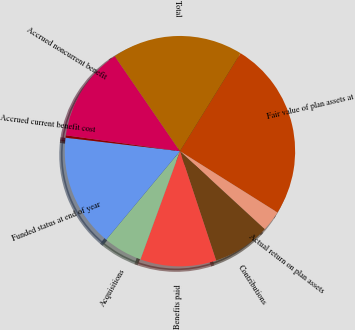Convert chart. <chart><loc_0><loc_0><loc_500><loc_500><pie_chart><fcel>Fair value of plan assets at<fcel>Actual return on plan assets<fcel>Contributions<fcel>Benefits paid<fcel>Acquisitions<fcel>Funded status at end of year<fcel>Accrued current benefit cost<fcel>Accrued noncurrent benefit<fcel>Total<nl><fcel>25.11%<fcel>2.91%<fcel>8.07%<fcel>10.65%<fcel>5.49%<fcel>15.81%<fcel>0.33%<fcel>13.23%<fcel>18.39%<nl></chart> 